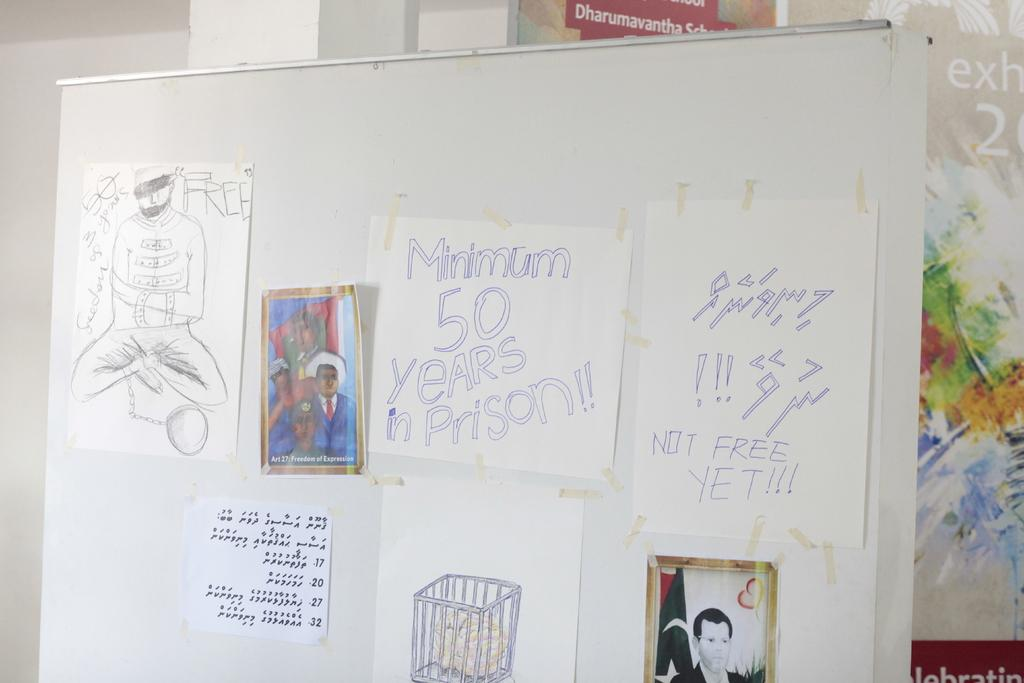<image>
Provide a brief description of the given image. A whiteboard with sketches of men and a cage, and two sheets of paper, one with minimum 50 years in prison, one with not free yet written on them. 